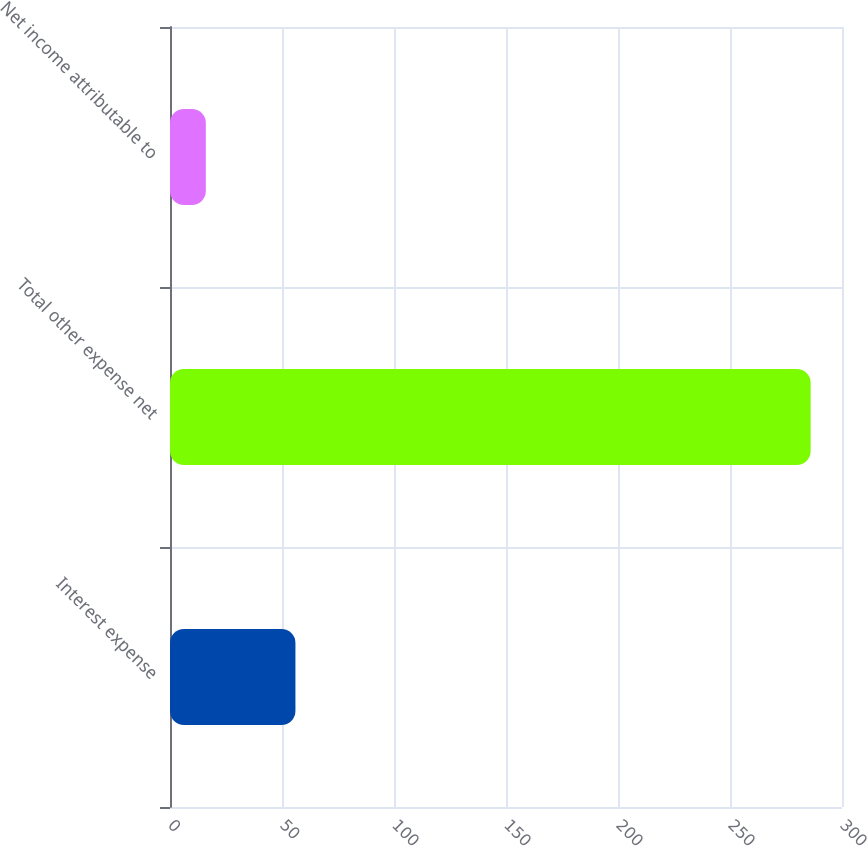<chart> <loc_0><loc_0><loc_500><loc_500><bar_chart><fcel>Interest expense<fcel>Total other expense net<fcel>Net income attributable to<nl><fcel>56<fcel>286<fcel>16<nl></chart> 